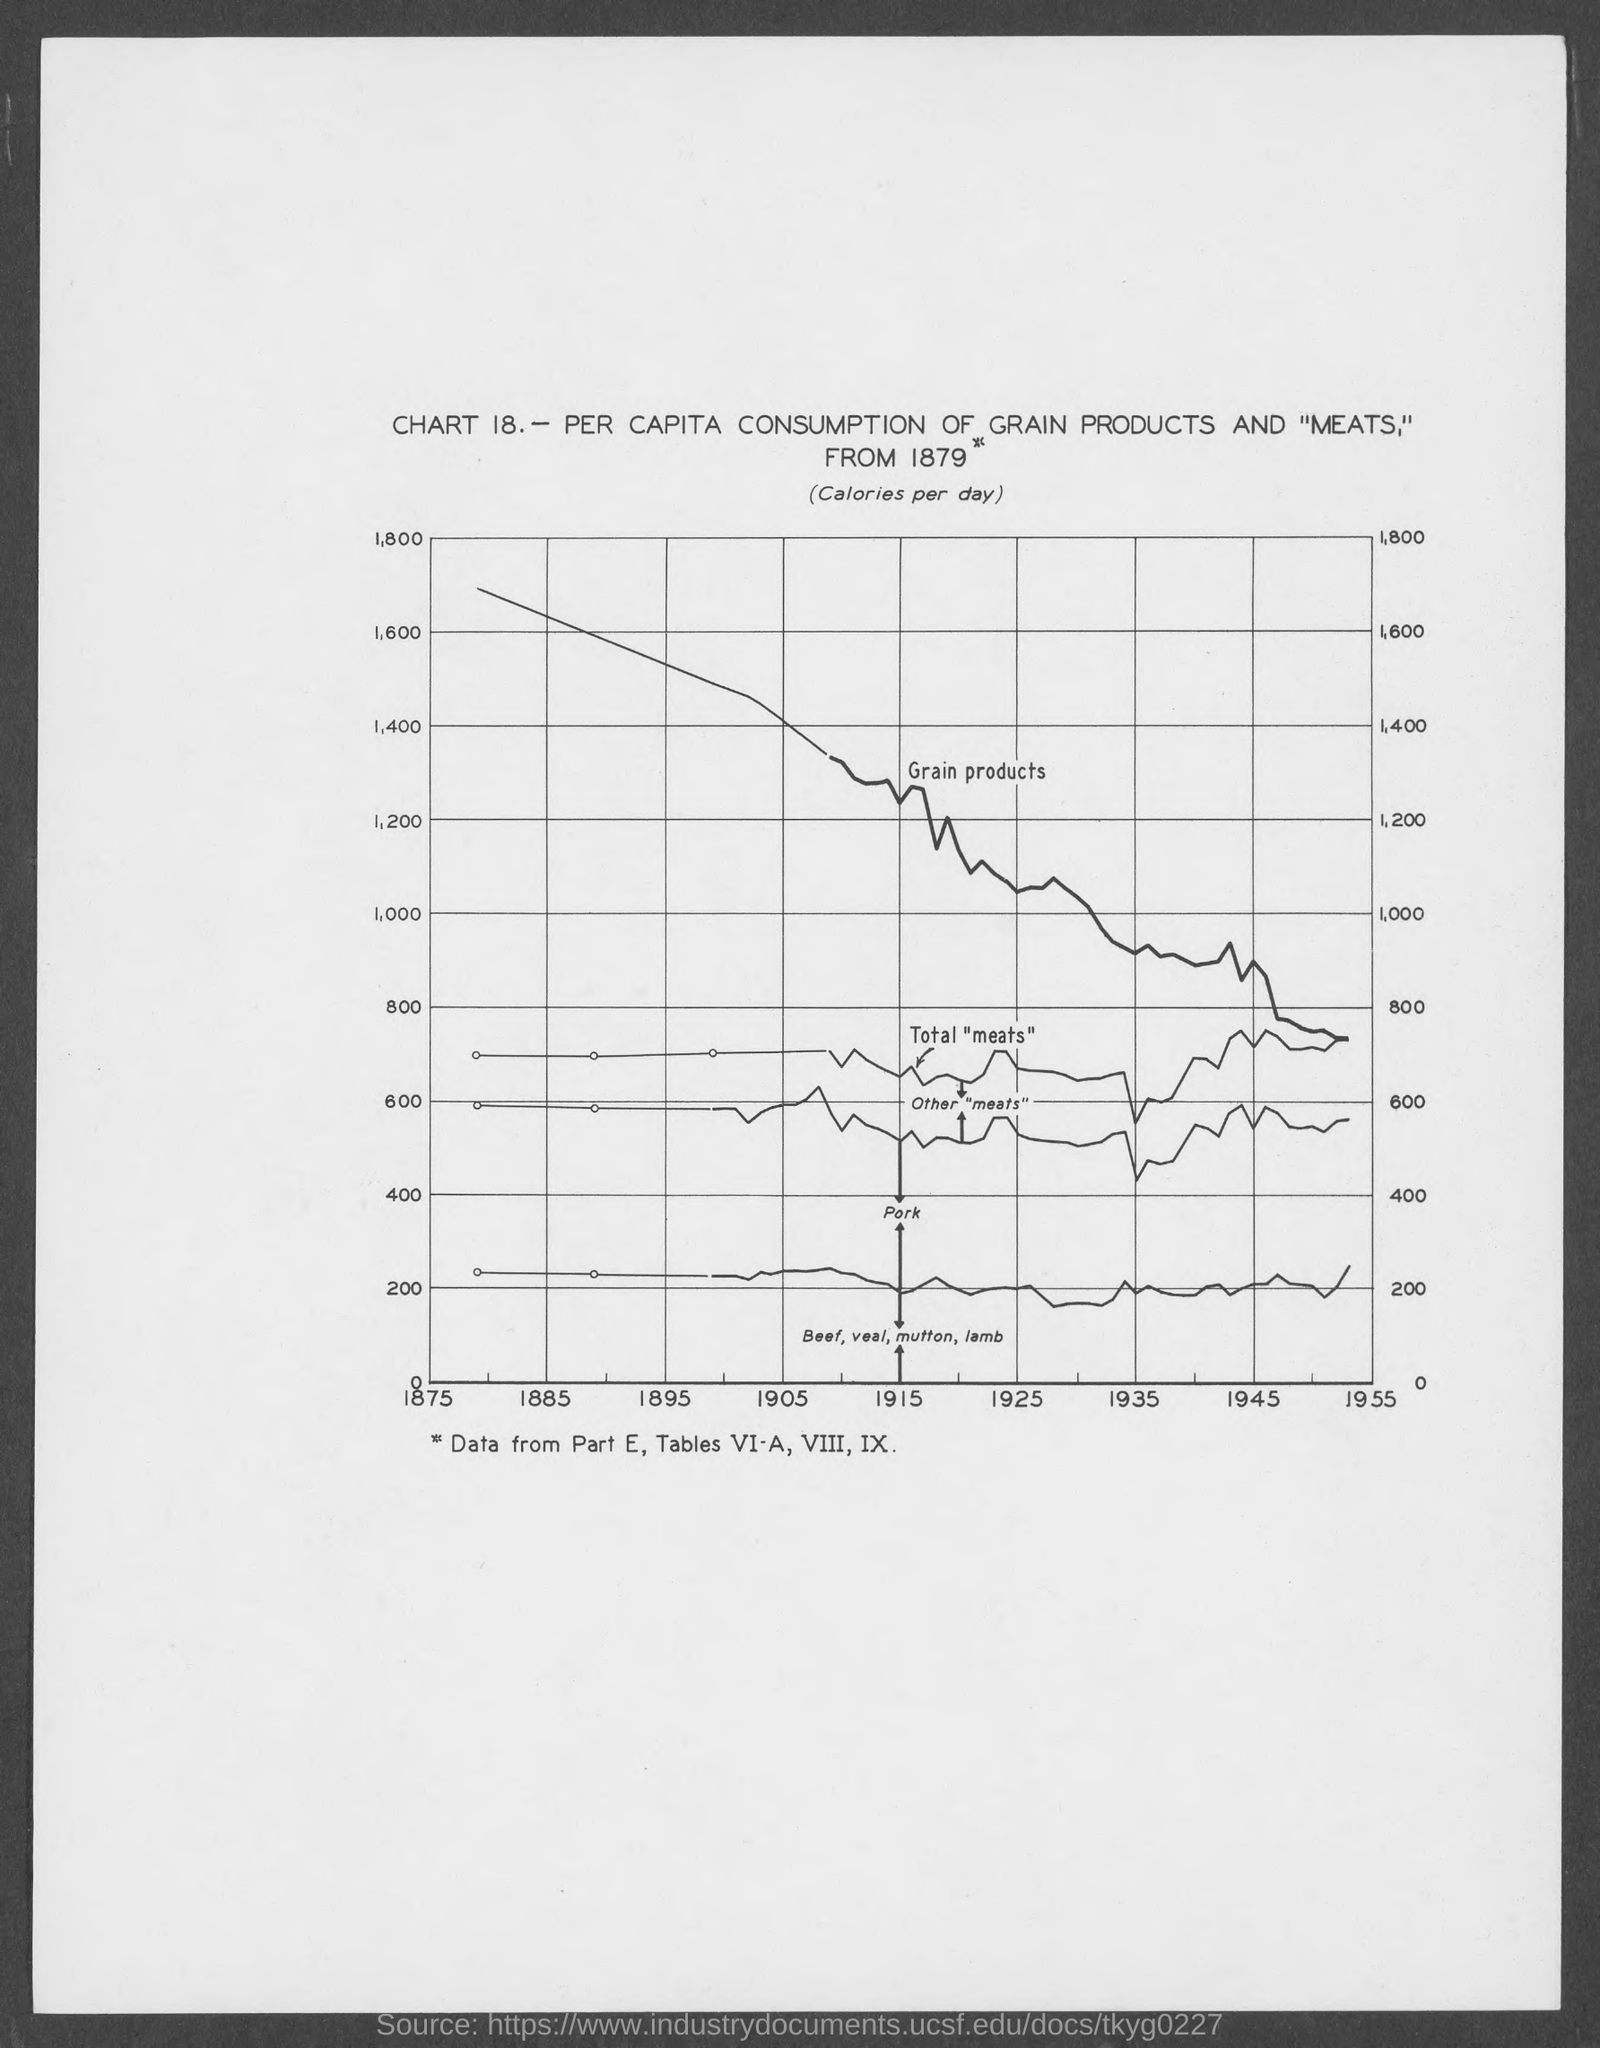Indicate a few pertinent items in this graphic. The part number is Part E. The chart number is X. The chart is named Chart 18... 